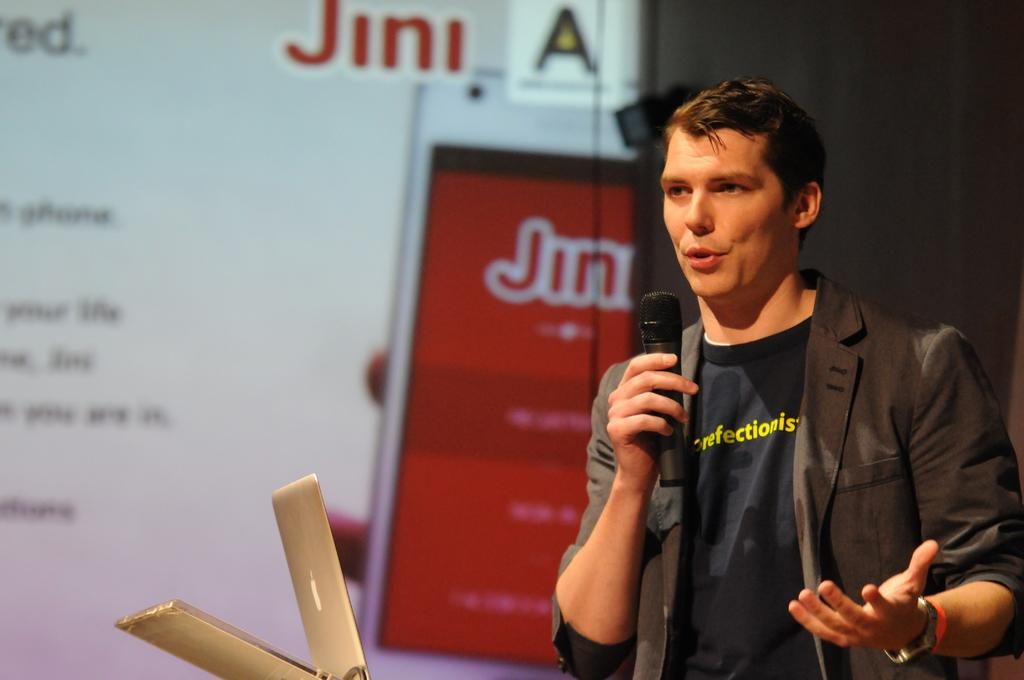Who is the main subject in the image? There is a man in the image. What is the man holding in the image? The man is holding a microphone. What device is in front of the man? There is a laptop in front of the man. What type of pickle is the man eating in the image? There is no pickle present in the image; the man is holding a microphone and there is a laptop in front of him. 